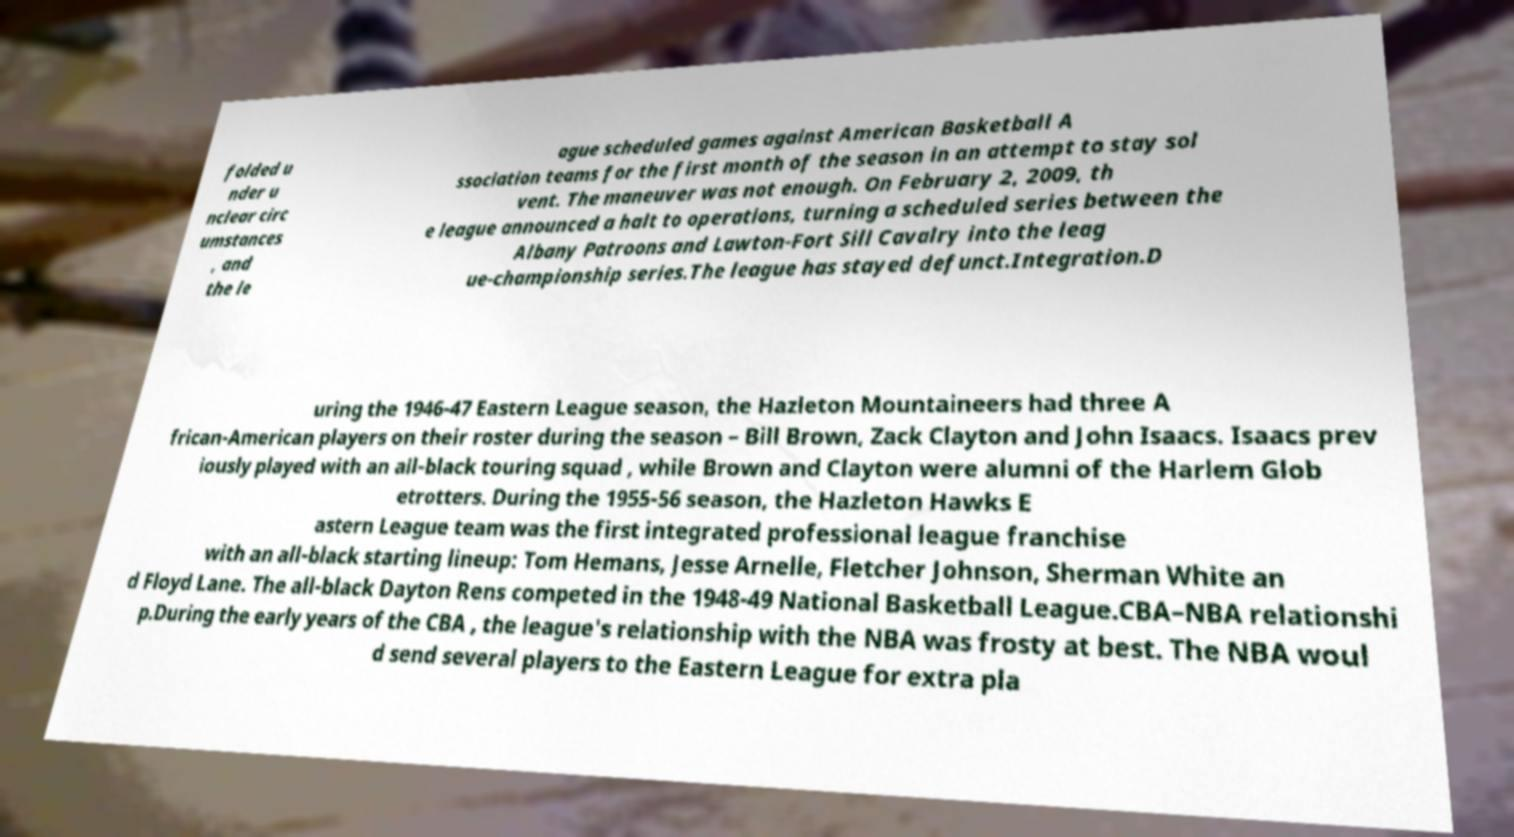Could you extract and type out the text from this image? folded u nder u nclear circ umstances , and the le ague scheduled games against American Basketball A ssociation teams for the first month of the season in an attempt to stay sol vent. The maneuver was not enough. On February 2, 2009, th e league announced a halt to operations, turning a scheduled series between the Albany Patroons and Lawton-Fort Sill Cavalry into the leag ue-championship series.The league has stayed defunct.Integration.D uring the 1946-47 Eastern League season, the Hazleton Mountaineers had three A frican-American players on their roster during the season – Bill Brown, Zack Clayton and John Isaacs. Isaacs prev iously played with an all-black touring squad , while Brown and Clayton were alumni of the Harlem Glob etrotters. During the 1955-56 season, the Hazleton Hawks E astern League team was the first integrated professional league franchise with an all-black starting lineup: Tom Hemans, Jesse Arnelle, Fletcher Johnson, Sherman White an d Floyd Lane. The all-black Dayton Rens competed in the 1948-49 National Basketball League.CBA–NBA relationshi p.During the early years of the CBA , the league's relationship with the NBA was frosty at best. The NBA woul d send several players to the Eastern League for extra pla 